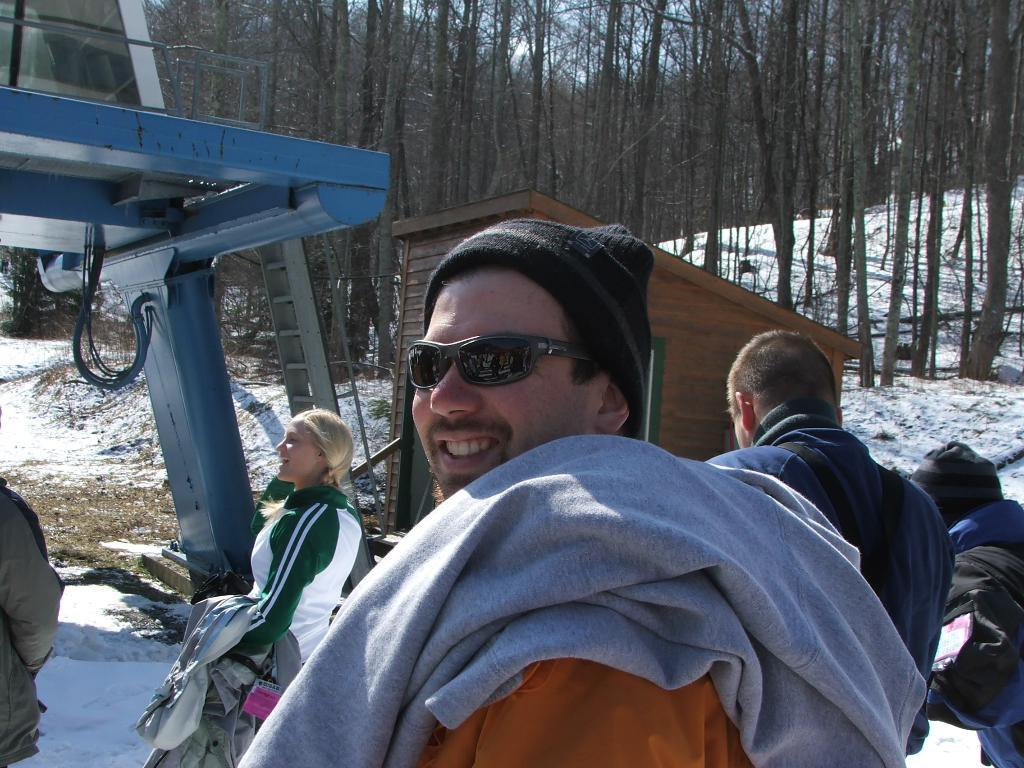What is the man in the image wearing on his face? The man is wearing goggles. What expression does the man have in the image? The man is smiling. What can be seen in the background of the image? There are people, a ladder, and trees in the background. What is the condition of the land in the image? The land is covered with snow. Can you see a yak playing basketball in the image? No, there is no yak or basketball present in the image. 